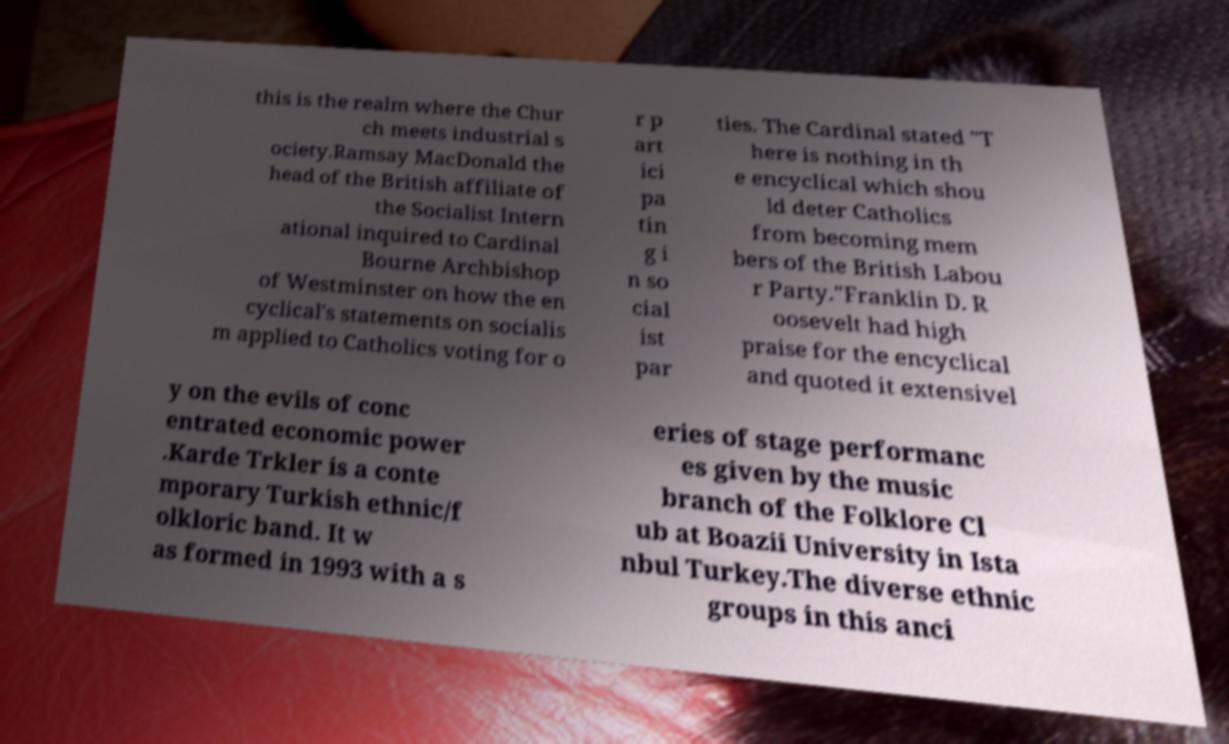Please read and relay the text visible in this image. What does it say? this is the realm where the Chur ch meets industrial s ociety.Ramsay MacDonald the head of the British affiliate of the Socialist Intern ational inquired to Cardinal Bourne Archbishop of Westminster on how the en cyclical's statements on socialis m applied to Catholics voting for o r p art ici pa tin g i n so cial ist par ties. The Cardinal stated "T here is nothing in th e encyclical which shou ld deter Catholics from becoming mem bers of the British Labou r Party."Franklin D. R oosevelt had high praise for the encyclical and quoted it extensivel y on the evils of conc entrated economic power .Karde Trkler is a conte mporary Turkish ethnic/f olkloric band. It w as formed in 1993 with a s eries of stage performanc es given by the music branch of the Folklore Cl ub at Boazii University in Ista nbul Turkey.The diverse ethnic groups in this anci 